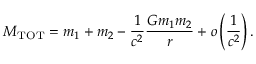Convert formula to latex. <formula><loc_0><loc_0><loc_500><loc_500>M _ { T O T } = m _ { 1 } + m _ { 2 } - \frac { 1 } { c ^ { 2 } } \frac { G m _ { 1 } m _ { 2 } } { r } + o \left ( \frac { 1 } { c ^ { 2 } } \right ) .</formula> 